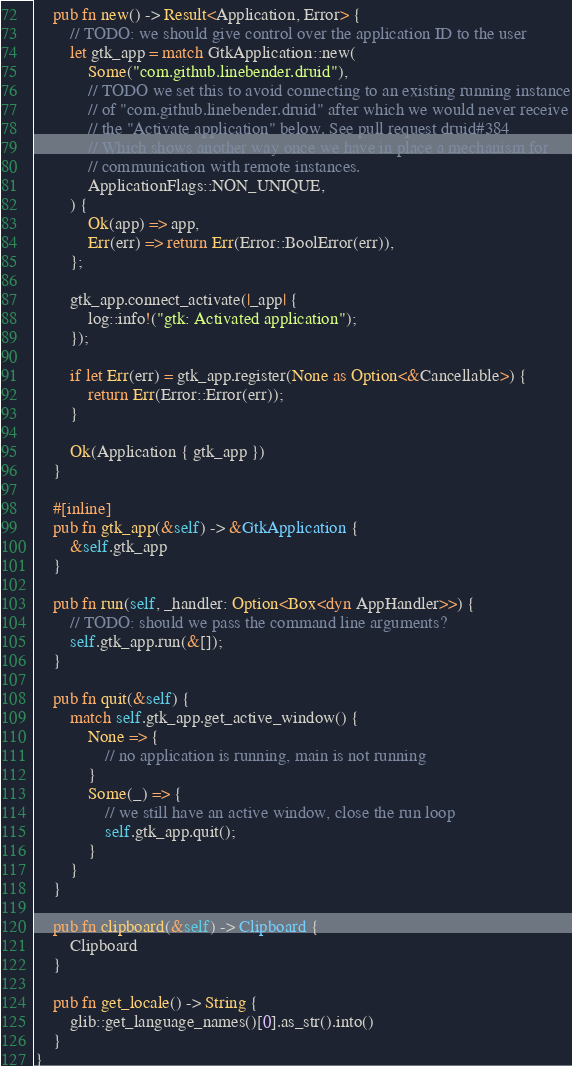Convert code to text. <code><loc_0><loc_0><loc_500><loc_500><_Rust_>    pub fn new() -> Result<Application, Error> {
        // TODO: we should give control over the application ID to the user
        let gtk_app = match GtkApplication::new(
            Some("com.github.linebender.druid"),
            // TODO we set this to avoid connecting to an existing running instance
            // of "com.github.linebender.druid" after which we would never receive
            // the "Activate application" below. See pull request druid#384
            // Which shows another way once we have in place a mechanism for
            // communication with remote instances.
            ApplicationFlags::NON_UNIQUE,
        ) {
            Ok(app) => app,
            Err(err) => return Err(Error::BoolError(err)),
        };

        gtk_app.connect_activate(|_app| {
            log::info!("gtk: Activated application");
        });

        if let Err(err) = gtk_app.register(None as Option<&Cancellable>) {
            return Err(Error::Error(err));
        }

        Ok(Application { gtk_app })
    }

    #[inline]
    pub fn gtk_app(&self) -> &GtkApplication {
        &self.gtk_app
    }

    pub fn run(self, _handler: Option<Box<dyn AppHandler>>) {
        // TODO: should we pass the command line arguments?
        self.gtk_app.run(&[]);
    }

    pub fn quit(&self) {
        match self.gtk_app.get_active_window() {
            None => {
                // no application is running, main is not running
            }
            Some(_) => {
                // we still have an active window, close the run loop
                self.gtk_app.quit();
            }
        }
    }

    pub fn clipboard(&self) -> Clipboard {
        Clipboard
    }

    pub fn get_locale() -> String {
        glib::get_language_names()[0].as_str().into()
    }
}
</code> 